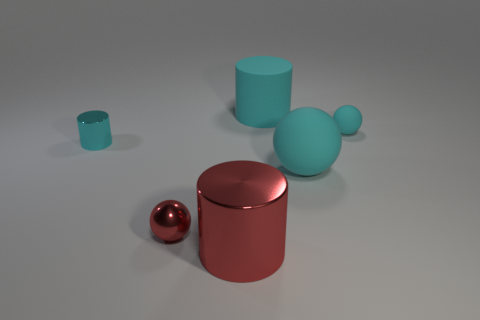Add 2 red cylinders. How many objects exist? 8 Add 3 red objects. How many red objects are left? 5 Add 2 cyan cylinders. How many cyan cylinders exist? 4 Subtract 0 red blocks. How many objects are left? 6 Subtract all rubber balls. Subtract all large red cylinders. How many objects are left? 3 